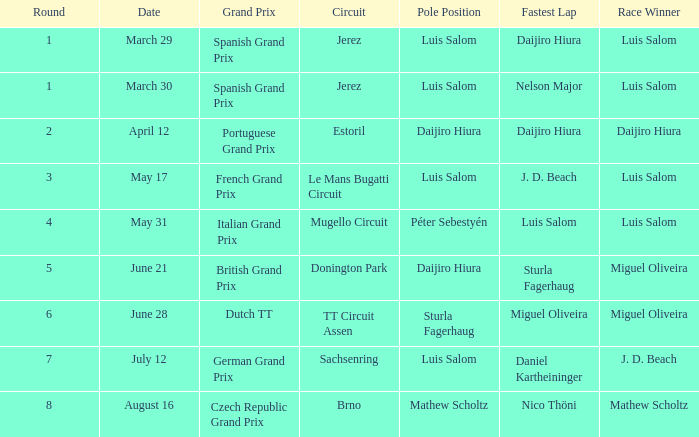Luis salom recorded the swiftest lap on which racecourses? Mugello Circuit. 